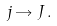<formula> <loc_0><loc_0><loc_500><loc_500>j \rightarrow J \, .</formula> 